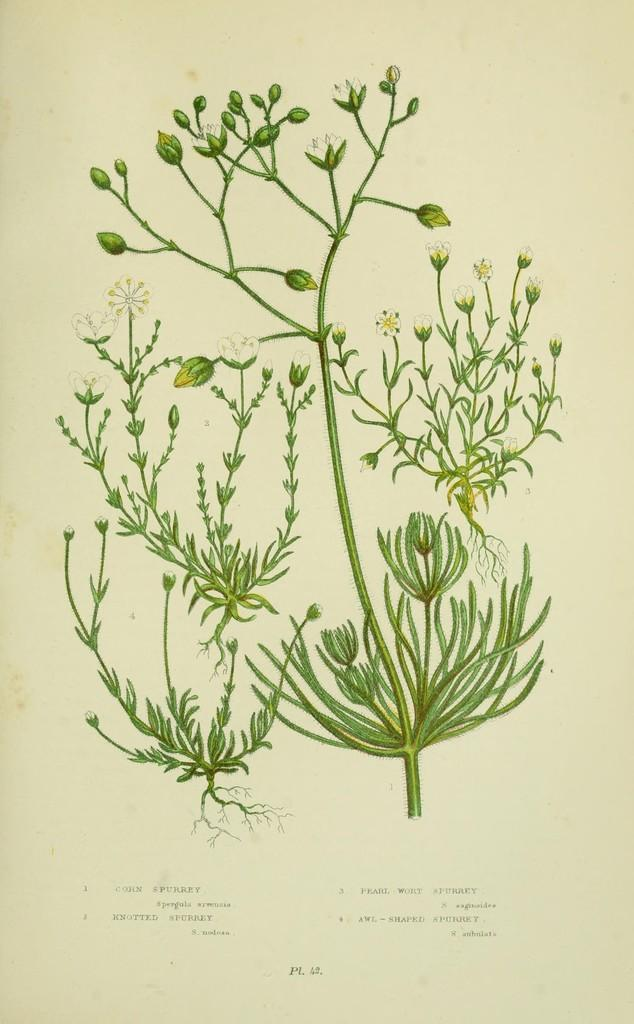What type of plants are in the image? There are green plants in the image. What color are the flowers in the image? There are white flowers in the image. Where are the plants and flowers located? The plants and flowers are on a paper. What else can be seen on the paper? There is writing on the paper. How does the hen interact with the rhythm in the image? There is no hen or rhythm present in the image; it only features green plants, white flowers, and writing on a paper. 